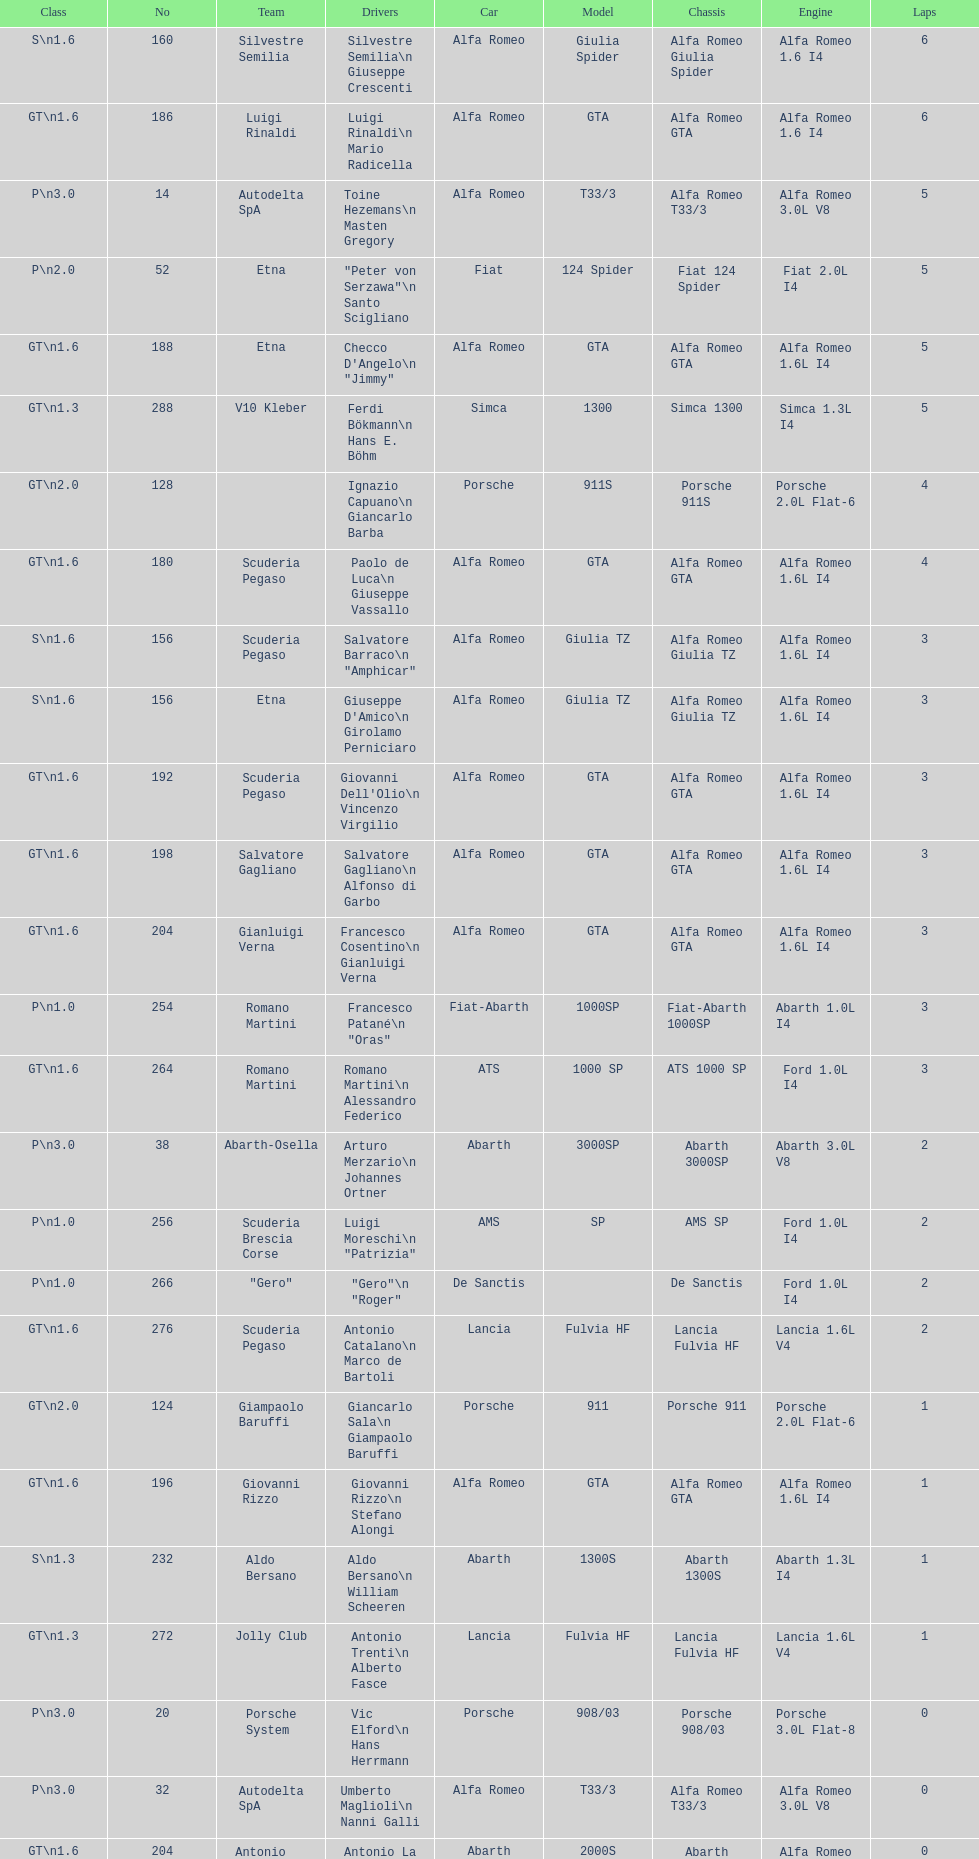Parse the full table. {'header': ['Class', 'No', 'Team', 'Drivers', 'Car', 'Model', 'Chassis', 'Engine', 'Laps'], 'rows': [['S\\n1.6', '160', 'Silvestre Semilia', 'Silvestre Semilia\\n Giuseppe Crescenti', 'Alfa Romeo', 'Giulia Spider', 'Alfa Romeo Giulia Spider', 'Alfa Romeo 1.6 I4', '6'], ['GT\\n1.6', '186', 'Luigi Rinaldi', 'Luigi Rinaldi\\n Mario Radicella', 'Alfa Romeo', 'GTA', 'Alfa Romeo GTA', 'Alfa Romeo 1.6 I4', '6'], ['P\\n3.0', '14', 'Autodelta SpA', 'Toine Hezemans\\n Masten Gregory', 'Alfa Romeo', 'T33/3', 'Alfa Romeo T33/3', 'Alfa Romeo 3.0L V8', '5'], ['P\\n2.0', '52', 'Etna', '"Peter von Serzawa"\\n Santo Scigliano', 'Fiat', '124 Spider', 'Fiat 124 Spider', 'Fiat 2.0L I4', '5'], ['GT\\n1.6', '188', 'Etna', 'Checco D\'Angelo\\n "Jimmy"', 'Alfa Romeo', 'GTA', 'Alfa Romeo GTA', 'Alfa Romeo 1.6L I4', '5'], ['GT\\n1.3', '288', 'V10 Kleber', 'Ferdi Bökmann\\n Hans E. Böhm', 'Simca', '1300', 'Simca 1300', 'Simca 1.3L I4', '5'], ['GT\\n2.0', '128', '', 'Ignazio Capuano\\n Giancarlo Barba', 'Porsche', '911S', 'Porsche 911S', 'Porsche 2.0L Flat-6', '4'], ['GT\\n1.6', '180', 'Scuderia Pegaso', 'Paolo de Luca\\n Giuseppe Vassallo', 'Alfa Romeo', 'GTA', 'Alfa Romeo GTA', 'Alfa Romeo 1.6L I4', '4'], ['S\\n1.6', '156', 'Scuderia Pegaso', 'Salvatore Barraco\\n "Amphicar"', 'Alfa Romeo', 'Giulia TZ', 'Alfa Romeo Giulia TZ', 'Alfa Romeo 1.6L I4', '3'], ['S\\n1.6', '156', 'Etna', "Giuseppe D'Amico\\n Girolamo Perniciaro", 'Alfa Romeo', 'Giulia TZ', 'Alfa Romeo Giulia TZ', 'Alfa Romeo 1.6L I4', '3'], ['GT\\n1.6', '192', 'Scuderia Pegaso', "Giovanni Dell'Olio\\n Vincenzo Virgilio", 'Alfa Romeo', 'GTA', 'Alfa Romeo GTA', 'Alfa Romeo 1.6L I4', '3'], ['GT\\n1.6', '198', 'Salvatore Gagliano', 'Salvatore Gagliano\\n Alfonso di Garbo', 'Alfa Romeo', 'GTA', 'Alfa Romeo GTA', 'Alfa Romeo 1.6L I4', '3'], ['GT\\n1.6', '204', 'Gianluigi Verna', 'Francesco Cosentino\\n Gianluigi Verna', 'Alfa Romeo', 'GTA', 'Alfa Romeo GTA', 'Alfa Romeo 1.6L I4', '3'], ['P\\n1.0', '254', 'Romano Martini', 'Francesco Patané\\n "Oras"', 'Fiat-Abarth', '1000SP', 'Fiat-Abarth 1000SP', 'Abarth 1.0L I4', '3'], ['GT\\n1.6', '264', 'Romano Martini', 'Romano Martini\\n Alessandro Federico', 'ATS', '1000 SP', 'ATS 1000 SP', 'Ford 1.0L I4', '3'], ['P\\n3.0', '38', 'Abarth-Osella', 'Arturo Merzario\\n Johannes Ortner', 'Abarth', '3000SP', 'Abarth 3000SP', 'Abarth 3.0L V8', '2'], ['P\\n1.0', '256', 'Scuderia Brescia Corse', 'Luigi Moreschi\\n "Patrizia"', 'AMS', 'SP', 'AMS SP', 'Ford 1.0L I4', '2'], ['P\\n1.0', '266', '"Gero"', '"Gero"\\n "Roger"', 'De Sanctis', '', 'De Sanctis', 'Ford 1.0L I4', '2'], ['GT\\n1.6', '276', 'Scuderia Pegaso', 'Antonio Catalano\\n Marco de Bartoli', 'Lancia', 'Fulvia HF', 'Lancia Fulvia HF', 'Lancia 1.6L V4', '2'], ['GT\\n2.0', '124', 'Giampaolo Baruffi', 'Giancarlo Sala\\n Giampaolo Baruffi', 'Porsche', '911', 'Porsche 911', 'Porsche 2.0L Flat-6', '1'], ['GT\\n1.6', '196', 'Giovanni Rizzo', 'Giovanni Rizzo\\n Stefano Alongi', 'Alfa Romeo', 'GTA', 'Alfa Romeo GTA', 'Alfa Romeo 1.6L I4', '1'], ['S\\n1.3', '232', 'Aldo Bersano', 'Aldo Bersano\\n William Scheeren', 'Abarth', '1300S', 'Abarth 1300S', 'Abarth 1.3L I4', '1'], ['GT\\n1.3', '272', 'Jolly Club', 'Antonio Trenti\\n Alberto Fasce', 'Lancia', 'Fulvia HF', 'Lancia Fulvia HF', 'Lancia 1.6L V4', '1'], ['P\\n3.0', '20', 'Porsche System', 'Vic Elford\\n Hans Herrmann', 'Porsche', '908/03', 'Porsche 908/03', 'Porsche 3.0L Flat-8', '0'], ['P\\n3.0', '32', 'Autodelta SpA', 'Umberto Maglioli\\n Nanni Galli', 'Alfa Romeo', 'T33/3', 'Alfa Romeo T33/3', 'Alfa Romeo 3.0L V8', '0'], ['GT\\n1.6', '204', 'Antonio Guagliardo', 'Antonio La Luce\\n Antonio Guagliardo', 'Abarth', '2000S', 'Abarth 2000S', 'Alfa Romeo 1.6L I4', '0'], ['P\\n1.3', '220', 'Jack Wheeler', 'Jack Wheeler\\n Martin Davidson', 'Jerboa', 'SP', 'Jerboa SP', 'BMC 1.3L I4', '0'], ['S\\n1.3', '234', 'Settecolli', 'Enzo Buzzetti\\n Gianni Marini', 'Abarth', '1300S', 'Abarth 1300S', 'Abarth 1.6L I4', '0'], ['GT\\n1.3', '280', 'Scuderia Pegaso', 'Giuseppe Chiaramonte\\n Giuseppe Spatafora', 'Lancia', 'Fulvia HF', 'Lancia Fulvia HF', 'Lancia 1.6L V4', '0']]} 6? GT 1.6. 